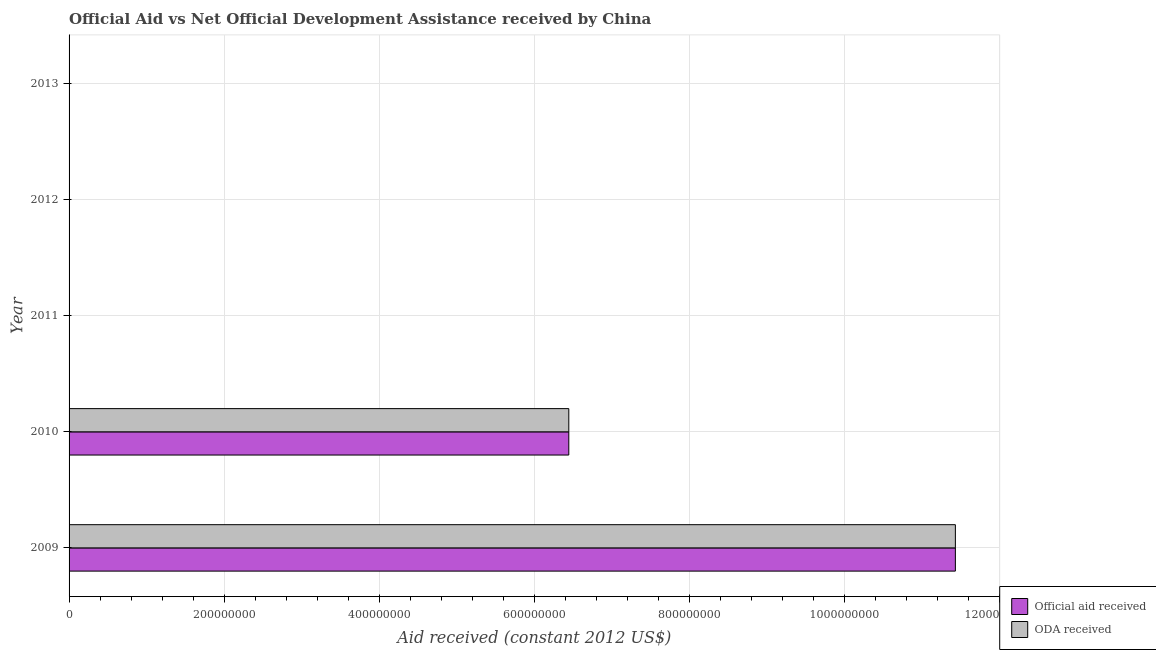Are the number of bars on each tick of the Y-axis equal?
Ensure brevity in your answer.  No. How many bars are there on the 5th tick from the bottom?
Keep it short and to the point. 0. What is the official aid received in 2010?
Offer a very short reply. 6.44e+08. Across all years, what is the maximum oda received?
Give a very brief answer. 1.14e+09. What is the total oda received in the graph?
Make the answer very short. 1.79e+09. What is the difference between the oda received in 2009 and that in 2010?
Your response must be concise. 4.99e+08. What is the difference between the official aid received in 2010 and the oda received in 2012?
Provide a succinct answer. 6.44e+08. What is the average official aid received per year?
Keep it short and to the point. 3.58e+08. In the year 2009, what is the difference between the oda received and official aid received?
Ensure brevity in your answer.  0. What is the ratio of the official aid received in 2009 to that in 2010?
Provide a short and direct response. 1.77. What is the difference between the highest and the lowest official aid received?
Ensure brevity in your answer.  1.14e+09. Are all the bars in the graph horizontal?
Make the answer very short. Yes. How many years are there in the graph?
Keep it short and to the point. 5. What is the difference between two consecutive major ticks on the X-axis?
Offer a terse response. 2.00e+08. Does the graph contain any zero values?
Your answer should be compact. Yes. Where does the legend appear in the graph?
Your response must be concise. Bottom right. How many legend labels are there?
Provide a succinct answer. 2. How are the legend labels stacked?
Keep it short and to the point. Vertical. What is the title of the graph?
Give a very brief answer. Official Aid vs Net Official Development Assistance received by China . What is the label or title of the X-axis?
Your response must be concise. Aid received (constant 2012 US$). What is the Aid received (constant 2012 US$) in Official aid received in 2009?
Offer a very short reply. 1.14e+09. What is the Aid received (constant 2012 US$) of ODA received in 2009?
Your answer should be very brief. 1.14e+09. What is the Aid received (constant 2012 US$) of Official aid received in 2010?
Make the answer very short. 6.44e+08. What is the Aid received (constant 2012 US$) in ODA received in 2010?
Provide a short and direct response. 6.44e+08. What is the Aid received (constant 2012 US$) in Official aid received in 2011?
Your answer should be compact. 0. What is the Aid received (constant 2012 US$) of ODA received in 2011?
Your response must be concise. 0. What is the Aid received (constant 2012 US$) of ODA received in 2013?
Keep it short and to the point. 0. Across all years, what is the maximum Aid received (constant 2012 US$) of Official aid received?
Your answer should be compact. 1.14e+09. Across all years, what is the maximum Aid received (constant 2012 US$) in ODA received?
Provide a succinct answer. 1.14e+09. Across all years, what is the minimum Aid received (constant 2012 US$) in Official aid received?
Offer a very short reply. 0. What is the total Aid received (constant 2012 US$) of Official aid received in the graph?
Ensure brevity in your answer.  1.79e+09. What is the total Aid received (constant 2012 US$) of ODA received in the graph?
Keep it short and to the point. 1.79e+09. What is the difference between the Aid received (constant 2012 US$) of Official aid received in 2009 and that in 2010?
Your answer should be very brief. 4.99e+08. What is the difference between the Aid received (constant 2012 US$) in ODA received in 2009 and that in 2010?
Offer a very short reply. 4.99e+08. What is the difference between the Aid received (constant 2012 US$) in Official aid received in 2009 and the Aid received (constant 2012 US$) in ODA received in 2010?
Give a very brief answer. 4.99e+08. What is the average Aid received (constant 2012 US$) of Official aid received per year?
Provide a succinct answer. 3.58e+08. What is the average Aid received (constant 2012 US$) of ODA received per year?
Provide a succinct answer. 3.58e+08. In the year 2009, what is the difference between the Aid received (constant 2012 US$) of Official aid received and Aid received (constant 2012 US$) of ODA received?
Make the answer very short. 0. In the year 2010, what is the difference between the Aid received (constant 2012 US$) in Official aid received and Aid received (constant 2012 US$) in ODA received?
Your answer should be compact. 0. What is the ratio of the Aid received (constant 2012 US$) in Official aid received in 2009 to that in 2010?
Provide a short and direct response. 1.77. What is the ratio of the Aid received (constant 2012 US$) of ODA received in 2009 to that in 2010?
Keep it short and to the point. 1.77. What is the difference between the highest and the lowest Aid received (constant 2012 US$) of Official aid received?
Provide a short and direct response. 1.14e+09. What is the difference between the highest and the lowest Aid received (constant 2012 US$) in ODA received?
Offer a very short reply. 1.14e+09. 